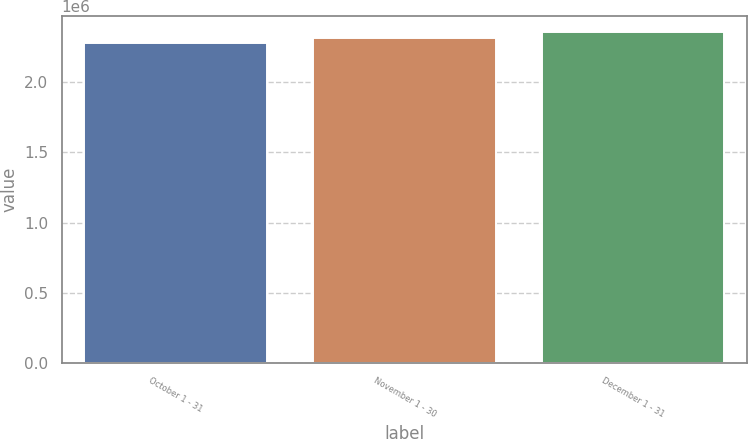Convert chart. <chart><loc_0><loc_0><loc_500><loc_500><bar_chart><fcel>October 1 - 31<fcel>November 1 - 30<fcel>December 1 - 31<nl><fcel>2.27645e+06<fcel>2.31486e+06<fcel>2.35307e+06<nl></chart> 